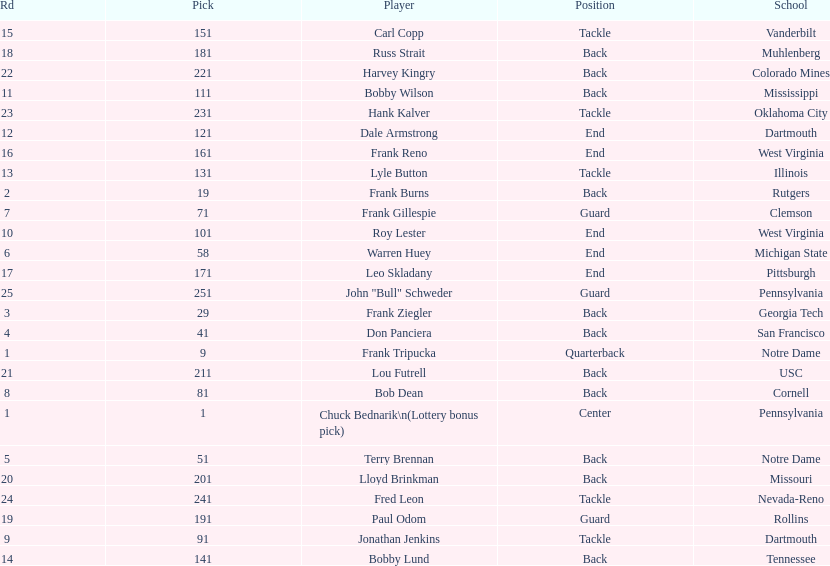Was chuck bednarik or frank tripucka the first draft pick? Chuck Bednarik. I'm looking to parse the entire table for insights. Could you assist me with that? {'header': ['Rd', 'Pick', 'Player', 'Position', 'School'], 'rows': [['15', '151', 'Carl Copp', 'Tackle', 'Vanderbilt'], ['18', '181', 'Russ Strait', 'Back', 'Muhlenberg'], ['22', '221', 'Harvey Kingry', 'Back', 'Colorado Mines'], ['11', '111', 'Bobby Wilson', 'Back', 'Mississippi'], ['23', '231', 'Hank Kalver', 'Tackle', 'Oklahoma City'], ['12', '121', 'Dale Armstrong', 'End', 'Dartmouth'], ['16', '161', 'Frank Reno', 'End', 'West Virginia'], ['13', '131', 'Lyle Button', 'Tackle', 'Illinois'], ['2', '19', 'Frank Burns', 'Back', 'Rutgers'], ['7', '71', 'Frank Gillespie', 'Guard', 'Clemson'], ['10', '101', 'Roy Lester', 'End', 'West Virginia'], ['6', '58', 'Warren Huey', 'End', 'Michigan State'], ['17', '171', 'Leo Skladany', 'End', 'Pittsburgh'], ['25', '251', 'John "Bull" Schweder', 'Guard', 'Pennsylvania'], ['3', '29', 'Frank Ziegler', 'Back', 'Georgia Tech'], ['4', '41', 'Don Panciera', 'Back', 'San Francisco'], ['1', '9', 'Frank Tripucka', 'Quarterback', 'Notre Dame'], ['21', '211', 'Lou Futrell', 'Back', 'USC'], ['8', '81', 'Bob Dean', 'Back', 'Cornell'], ['1', '1', 'Chuck Bednarik\\n(Lottery bonus pick)', 'Center', 'Pennsylvania'], ['5', '51', 'Terry Brennan', 'Back', 'Notre Dame'], ['20', '201', 'Lloyd Brinkman', 'Back', 'Missouri'], ['24', '241', 'Fred Leon', 'Tackle', 'Nevada-Reno'], ['19', '191', 'Paul Odom', 'Guard', 'Rollins'], ['9', '91', 'Jonathan Jenkins', 'Tackle', 'Dartmouth'], ['14', '141', 'Bobby Lund', 'Back', 'Tennessee']]} 